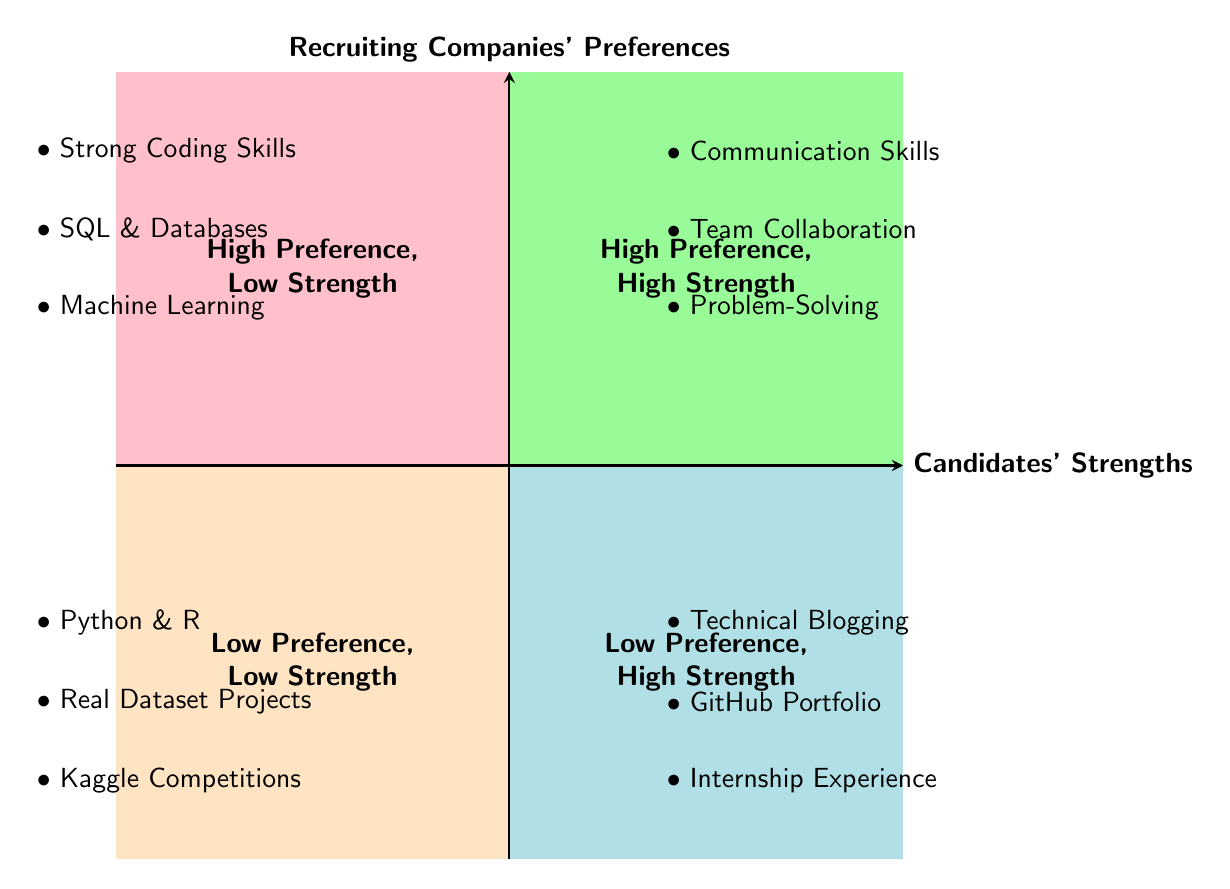What are the strengths listed in the low preference, low strength quadrant? The low preference, low strength quadrant is located at the bottom-left of the diagram. The strengths listed there are "Python and R," "Real Dataset Projects," and "Kaggle Competitions."
Answer: Python and R, Real Dataset Projects, Kaggle Competitions Which candidate strength corresponds to high preference and low strength? The high preference, low strength quadrant is located at the top-left of the diagram. The strengths listed there correspond to candidates' abilities without high appeal to recruiting companies. The strength in this quadrant is "Proficiency in Python and R."
Answer: Proficiency in Python and R How many recruiting company preferences are shown in the diagram? The diagram lists six recruiting companies' preferences located on the left side of the chart, including "Strong Coding Skills," "Experience with SQL and Databases," "Understanding of Machine Learning Concepts," "Effective Communication Skills," "Team Collaboration," and "Problem-Solving Aptitude." Counting these preferences results in six entries.
Answer: 6 Which strength is regarded as high preference and high strength? The high preference, high strength quadrant is in the top-right section of the diagram. It includes strengths that match both companies' preferences and candidates' abilities. One such strength listed is "Technical Blog Writing."
Answer: Technical Blog Writing Which candidate strength is least aligned with recruiting company preferences? The candidate strengths listed in the low preference, low strength quadrant are least aligned with recruiting companies' needs. There are three strengths in this quadrant, and one of them is "Kaggle Competitions Participation," which reflects personal experience that might not align with prevailing industry demands.
Answer: Kaggle Competitions Participation What is the purpose of this quadrant chart? The purpose of this quadrant chart is to visually represent the relationship between recruiting companies' preferences and candidates' strengths, indicating alignment or misalignment between the two and helping both parties identify valuable areas for development or focus.
Answer: Visual representation of preferences and strengths 